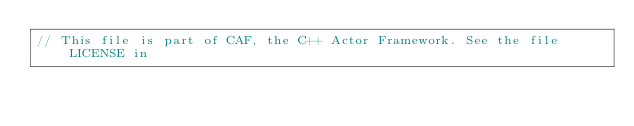<code> <loc_0><loc_0><loc_500><loc_500><_C++_>// This file is part of CAF, the C++ Actor Framework. See the file LICENSE in</code> 